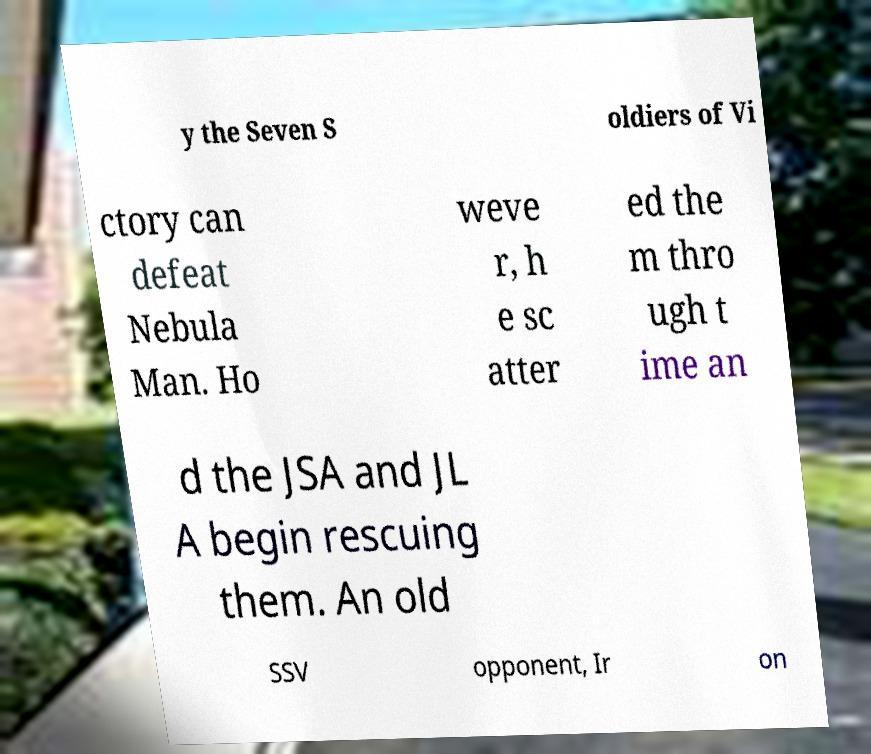There's text embedded in this image that I need extracted. Can you transcribe it verbatim? y the Seven S oldiers of Vi ctory can defeat Nebula Man. Ho weve r, h e sc atter ed the m thro ugh t ime an d the JSA and JL A begin rescuing them. An old SSV opponent, Ir on 